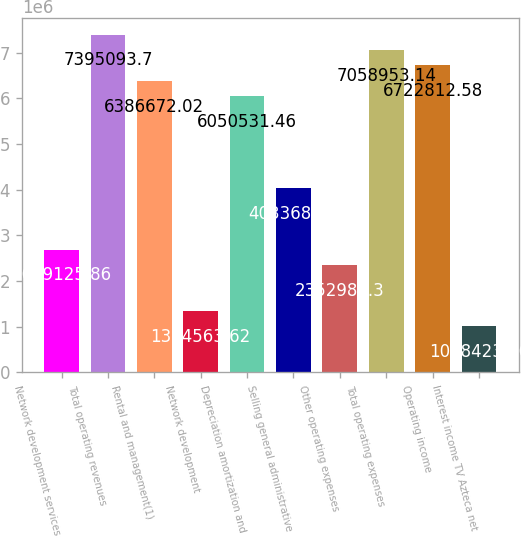Convert chart. <chart><loc_0><loc_0><loc_500><loc_500><bar_chart><fcel>Network development services<fcel>Total operating revenues<fcel>Rental and management(1)<fcel>Network development<fcel>Depreciation amortization and<fcel>Selling general administrative<fcel>Other operating expenses<fcel>Total operating expenses<fcel>Operating income<fcel>Interest income TV Azteca net<nl><fcel>2.68913e+06<fcel>7.39509e+06<fcel>6.38667e+06<fcel>1.34456e+06<fcel>6.05053e+06<fcel>4.03369e+06<fcel>2.35299e+06<fcel>7.05895e+06<fcel>6.72281e+06<fcel>1.00842e+06<nl></chart> 